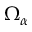<formula> <loc_0><loc_0><loc_500><loc_500>\Omega _ { \alpha }</formula> 